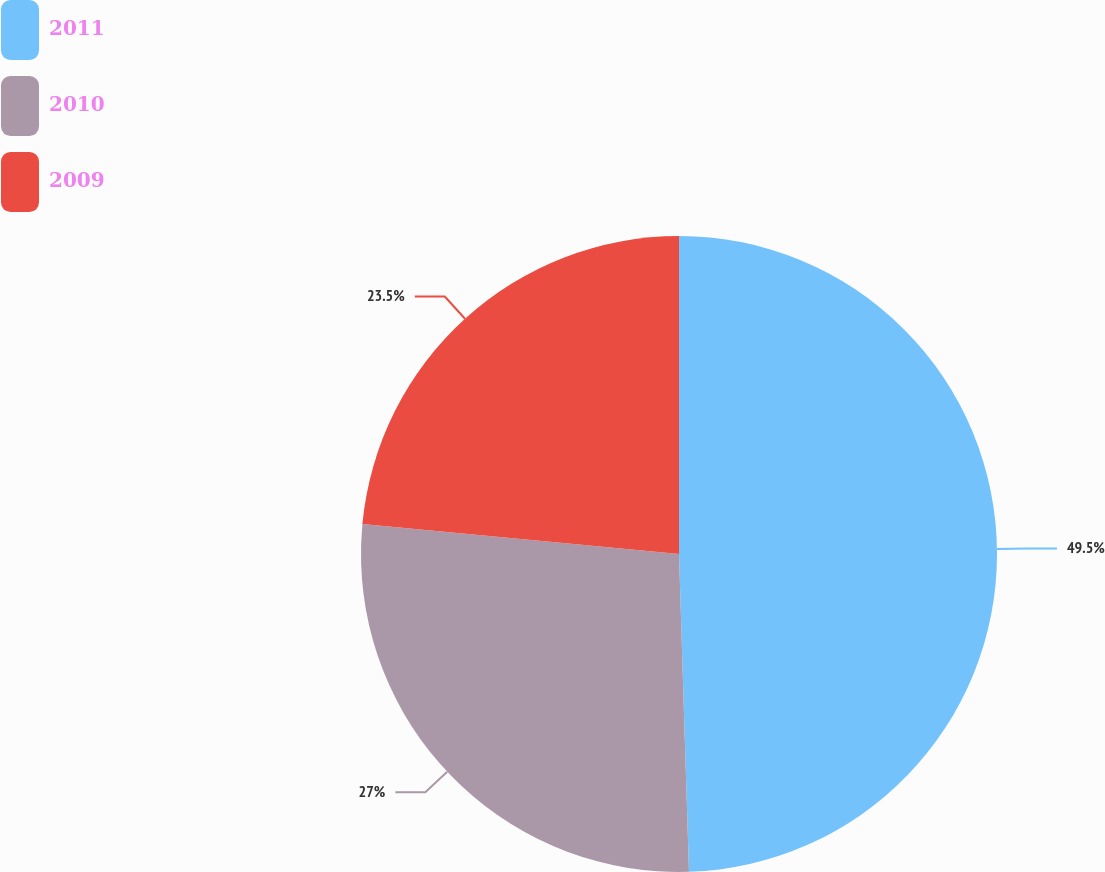<chart> <loc_0><loc_0><loc_500><loc_500><pie_chart><fcel>2011<fcel>2010<fcel>2009<nl><fcel>49.5%<fcel>27.0%<fcel>23.5%<nl></chart> 